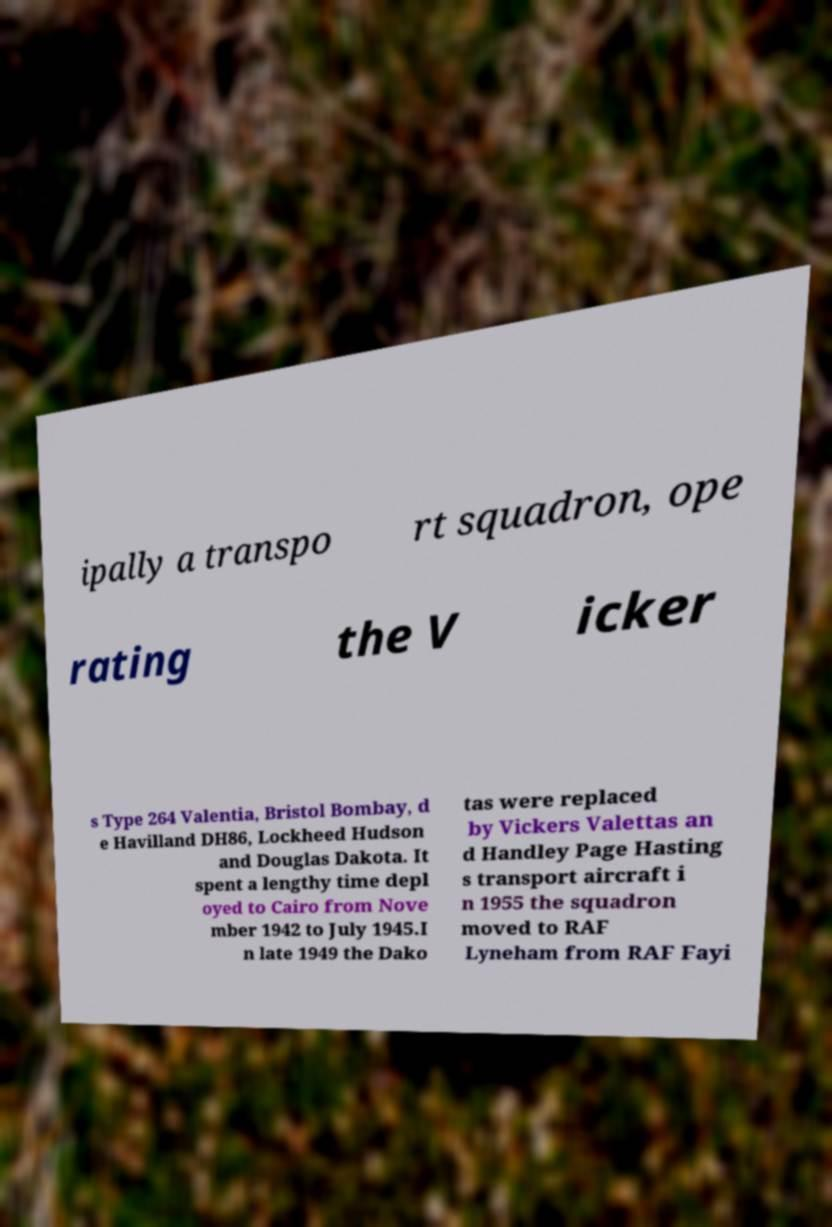Can you read and provide the text displayed in the image?This photo seems to have some interesting text. Can you extract and type it out for me? ipally a transpo rt squadron, ope rating the V icker s Type 264 Valentia, Bristol Bombay, d e Havilland DH86, Lockheed Hudson and Douglas Dakota. It spent a lengthy time depl oyed to Cairo from Nove mber 1942 to July 1945.I n late 1949 the Dako tas were replaced by Vickers Valettas an d Handley Page Hasting s transport aircraft i n 1955 the squadron moved to RAF Lyneham from RAF Fayi 